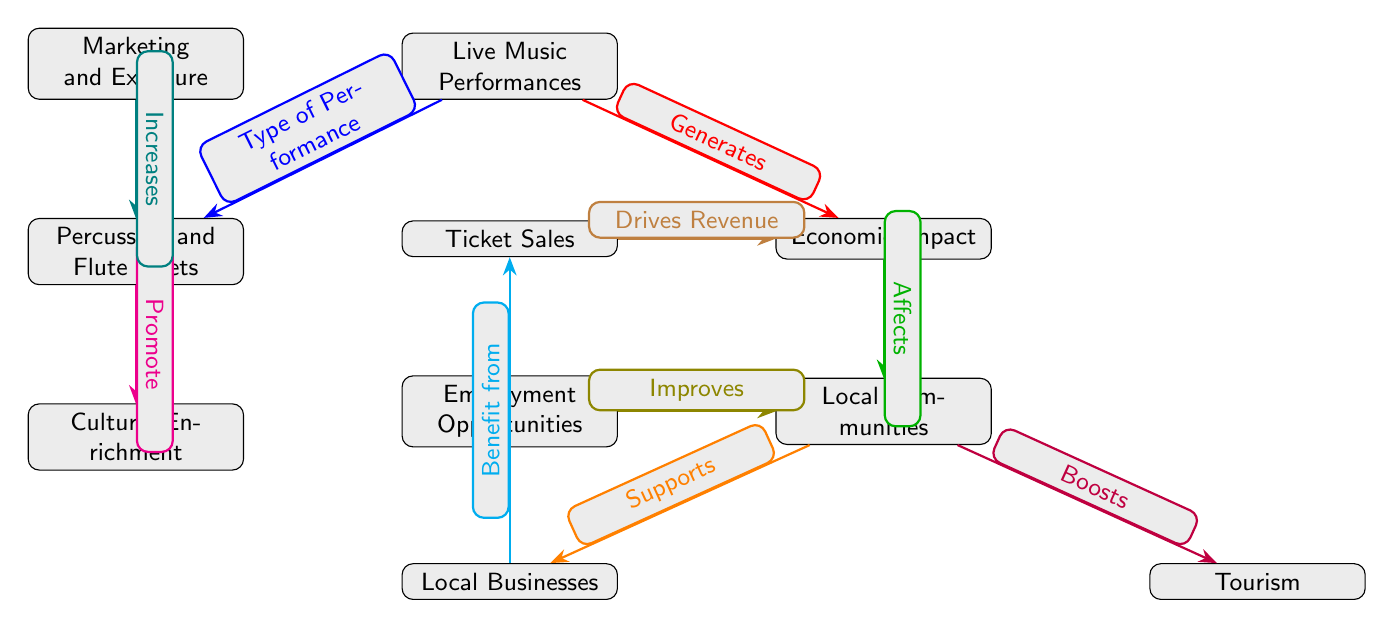What are the two types of performances mentioned in the diagram? The diagram lists "Live Music Performances" and specifies "Percussion and Flute Duets" as a type of performance underneath it.
Answer: Percussion and Flute Duets What is the primary economic impact identified in the diagram? The main economic impact identified in the diagram is labeled as "Economic Impact" connected directly from "Live Music Performances" and leads to "Local Communities."
Answer: Economic Impact How many nodes are there in the diagram? By counting the distinct elements in the diagram—including "Live Music Performances," "Percussion and Flute Duets," "Economic Impact," "Local Communities," "Ticket Sales," "Local Businesses," "Tourism," "Cultural Enrichment," "Employment Opportunities," and "Marketing and Exposure"—there are a total of ten nodes.
Answer: 10 What drives revenue according to the diagram? The diagram indicates that "Ticket Sales" drive revenue, which is connected to the "Economic Impact."
Answer: Ticket Sales Which aspect is boosted by economic impact in local communities? The diagram specifies that "Tourism" is boosted as a result of the economic impact on local communities, which is indicated by the label "Boosts" issuing from "Economic Impact" to "Tourism."
Answer: Tourism How does marketing and exposure relate to percussion and flute duets? The diagram states that "Marketing and Exposure" increases the visibility of "Percussion and Flute Duets," indicating that there is a direct upward connection labeled "Increases" from "Marketing and Exposure" to "Percussion and Flute Duets."
Answer: Increases What type of relationship exists between local businesses and local communities? The diagram indicates a supportive relationship where local businesses are supported by the economic impact on local communities, shown by the edge labeled "Supports."
Answer: Supports How many paths lead from live music performances to the economic impact? There are two direct paths leading from "Live Music Performances" to "Economic Impact": one connects directly as "Generates," and another connects indirectly through "Ticket Sales."
Answer: 2 What enhances cultural enrichment according to the diagram? The diagram shows that "Percussion and Flute Duets" promote "Cultural Enrichment," indicated by the connection labeled "Promote."
Answer: Promote 